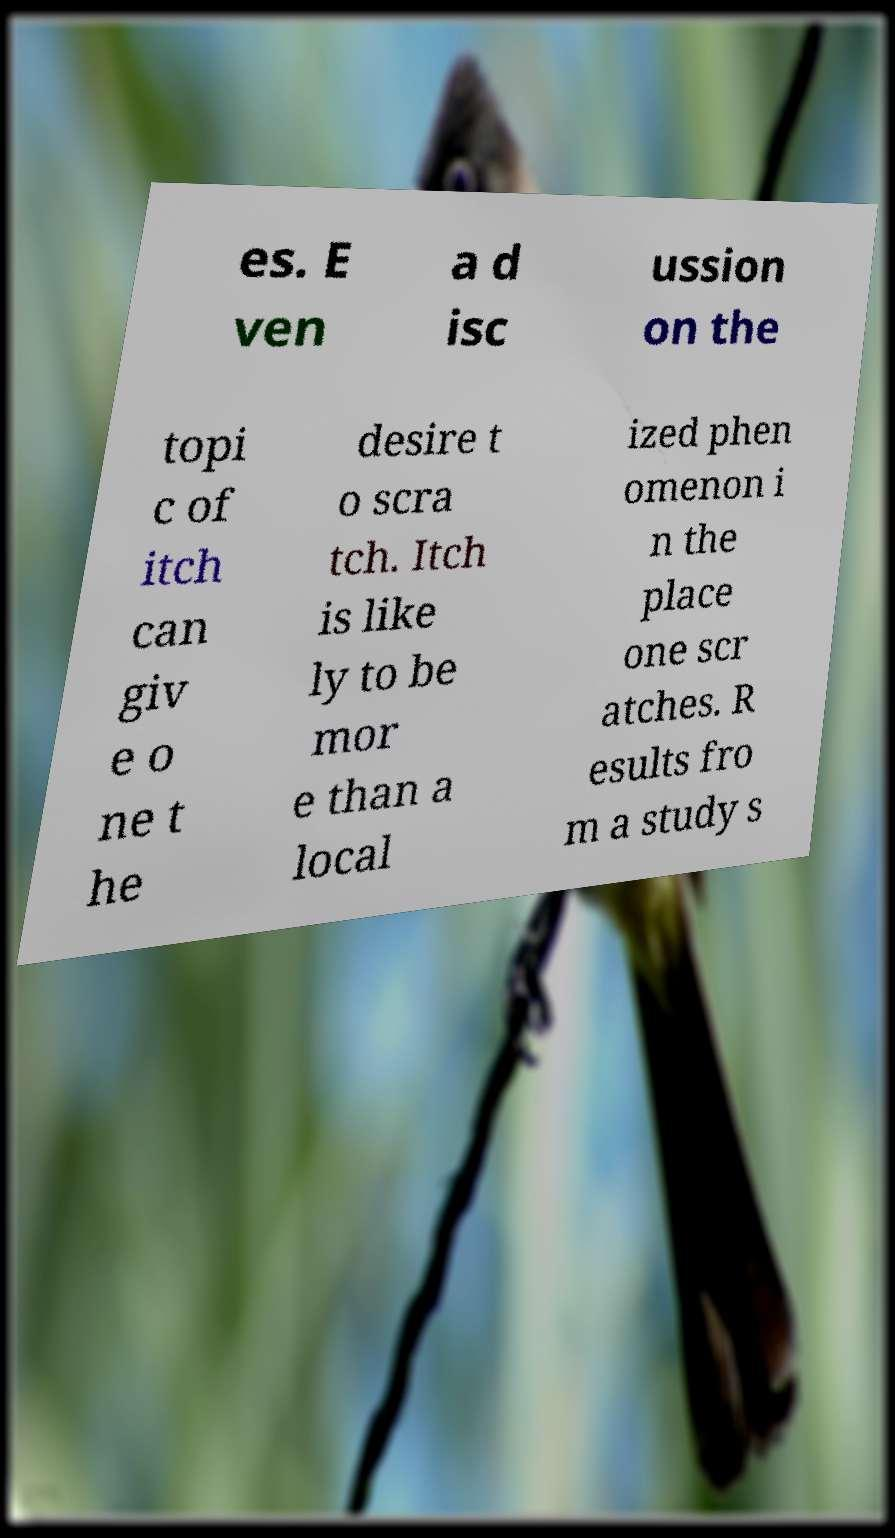Can you accurately transcribe the text from the provided image for me? es. E ven a d isc ussion on the topi c of itch can giv e o ne t he desire t o scra tch. Itch is like ly to be mor e than a local ized phen omenon i n the place one scr atches. R esults fro m a study s 